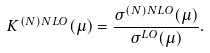<formula> <loc_0><loc_0><loc_500><loc_500>K ^ { ( N ) N L O } ( \mu ) = \frac { \sigma ^ { ( N ) N L O } ( \mu ) } { \sigma ^ { L O } ( \mu ) } .</formula> 